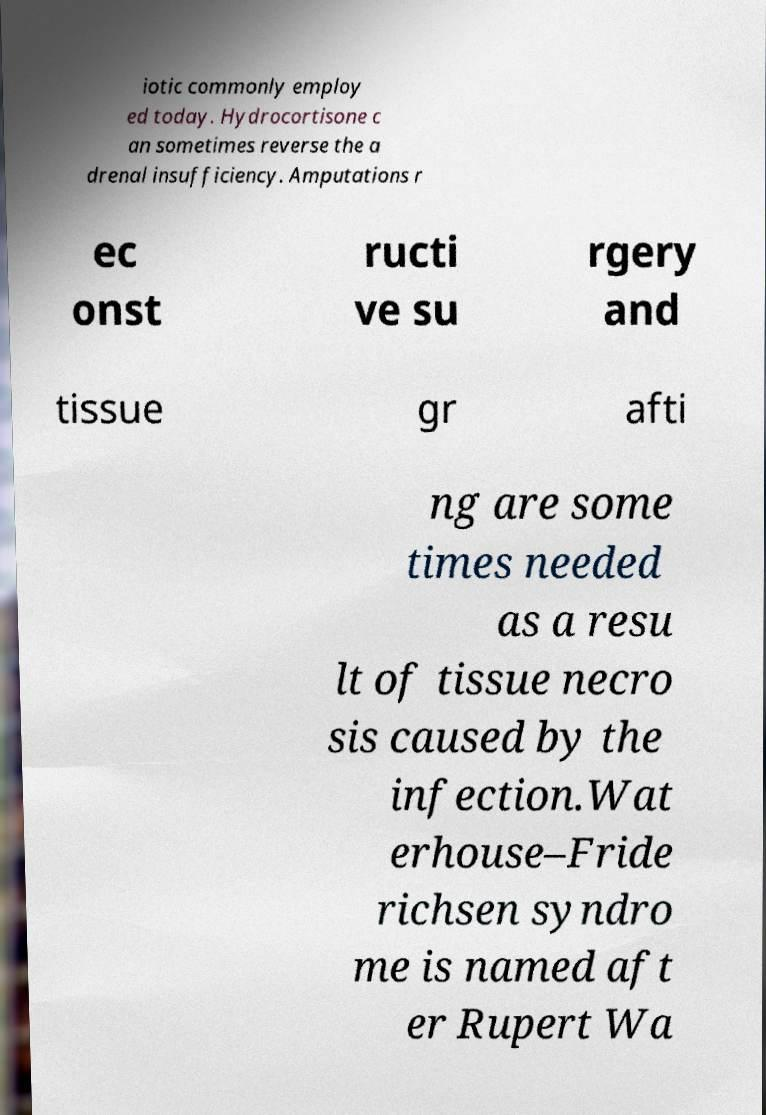What messages or text are displayed in this image? I need them in a readable, typed format. iotic commonly employ ed today. Hydrocortisone c an sometimes reverse the a drenal insufficiency. Amputations r ec onst ructi ve su rgery and tissue gr afti ng are some times needed as a resu lt of tissue necro sis caused by the infection.Wat erhouse–Fride richsen syndro me is named aft er Rupert Wa 